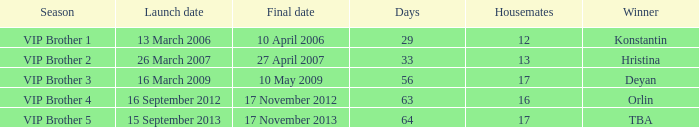What final date had 16 housemates? 17 November 2012. Help me parse the entirety of this table. {'header': ['Season', 'Launch date', 'Final date', 'Days', 'Housemates', 'Winner'], 'rows': [['VIP Brother 1', '13 March 2006', '10 April 2006', '29', '12', 'Konstantin'], ['VIP Brother 2', '26 March 2007', '27 April 2007', '33', '13', 'Hristina'], ['VIP Brother 3', '16 March 2009', '10 May 2009', '56', '17', 'Deyan'], ['VIP Brother 4', '16 September 2012', '17 November 2012', '63', '16', 'Orlin'], ['VIP Brother 5', '15 September 2013', '17 November 2013', '64', '17', 'TBA']]} 